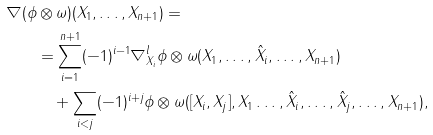<formula> <loc_0><loc_0><loc_500><loc_500>\nabla ( \phi & \otimes \omega ) ( X _ { 1 } , \dots , X _ { n + 1 } ) = \\ & = \sum _ { i = 1 } ^ { n + 1 } ( - 1 ) ^ { i - 1 } \nabla ^ { l } _ { X _ { i } } \phi \otimes \omega ( X _ { 1 } , \dots , \hat { X } _ { i } , \dots , X _ { n + 1 } ) \\ & \quad + \sum _ { i < j } ( - 1 ) ^ { i + j } \phi \otimes \omega ( [ X _ { i } , X _ { j } ] , X _ { 1 } \dots , \hat { X } _ { i } , \dots , \hat { X } _ { j } , \dots , X _ { n + 1 } ) ,</formula> 